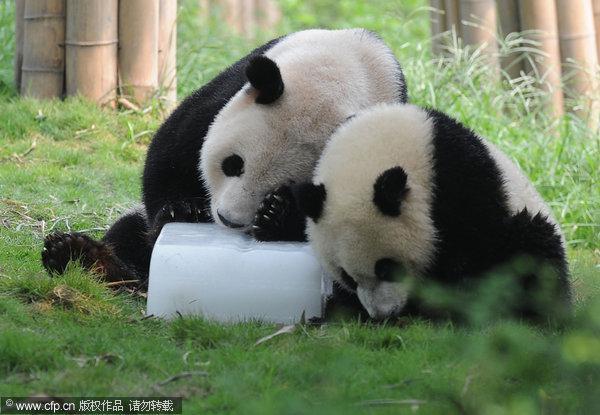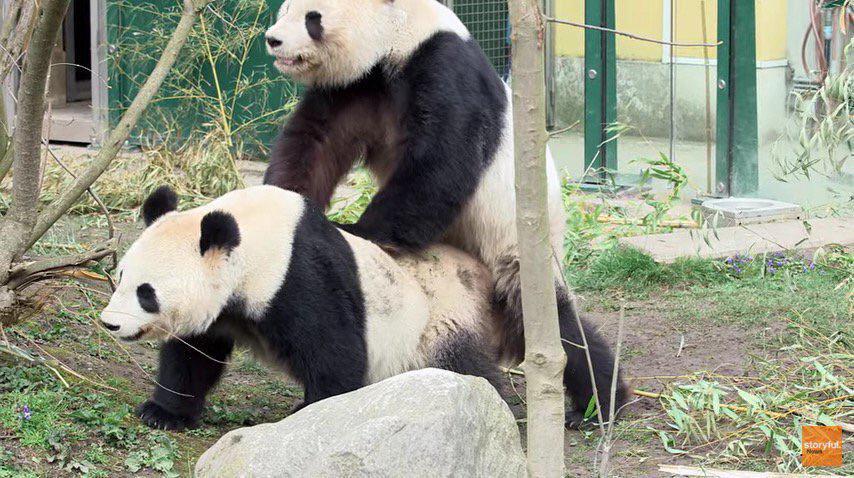The first image is the image on the left, the second image is the image on the right. For the images displayed, is the sentence "One image shows a panda with its front paws on a large tree trunk, and the other image shows two pandas, one on top with its front paws on the other." factually correct? Answer yes or no. No. The first image is the image on the left, the second image is the image on the right. Evaluate the accuracy of this statement regarding the images: "there are pandas mating next to a rock which is next to a tree trunk with windowed fencing and green posts in the back ground". Is it true? Answer yes or no. Yes. 